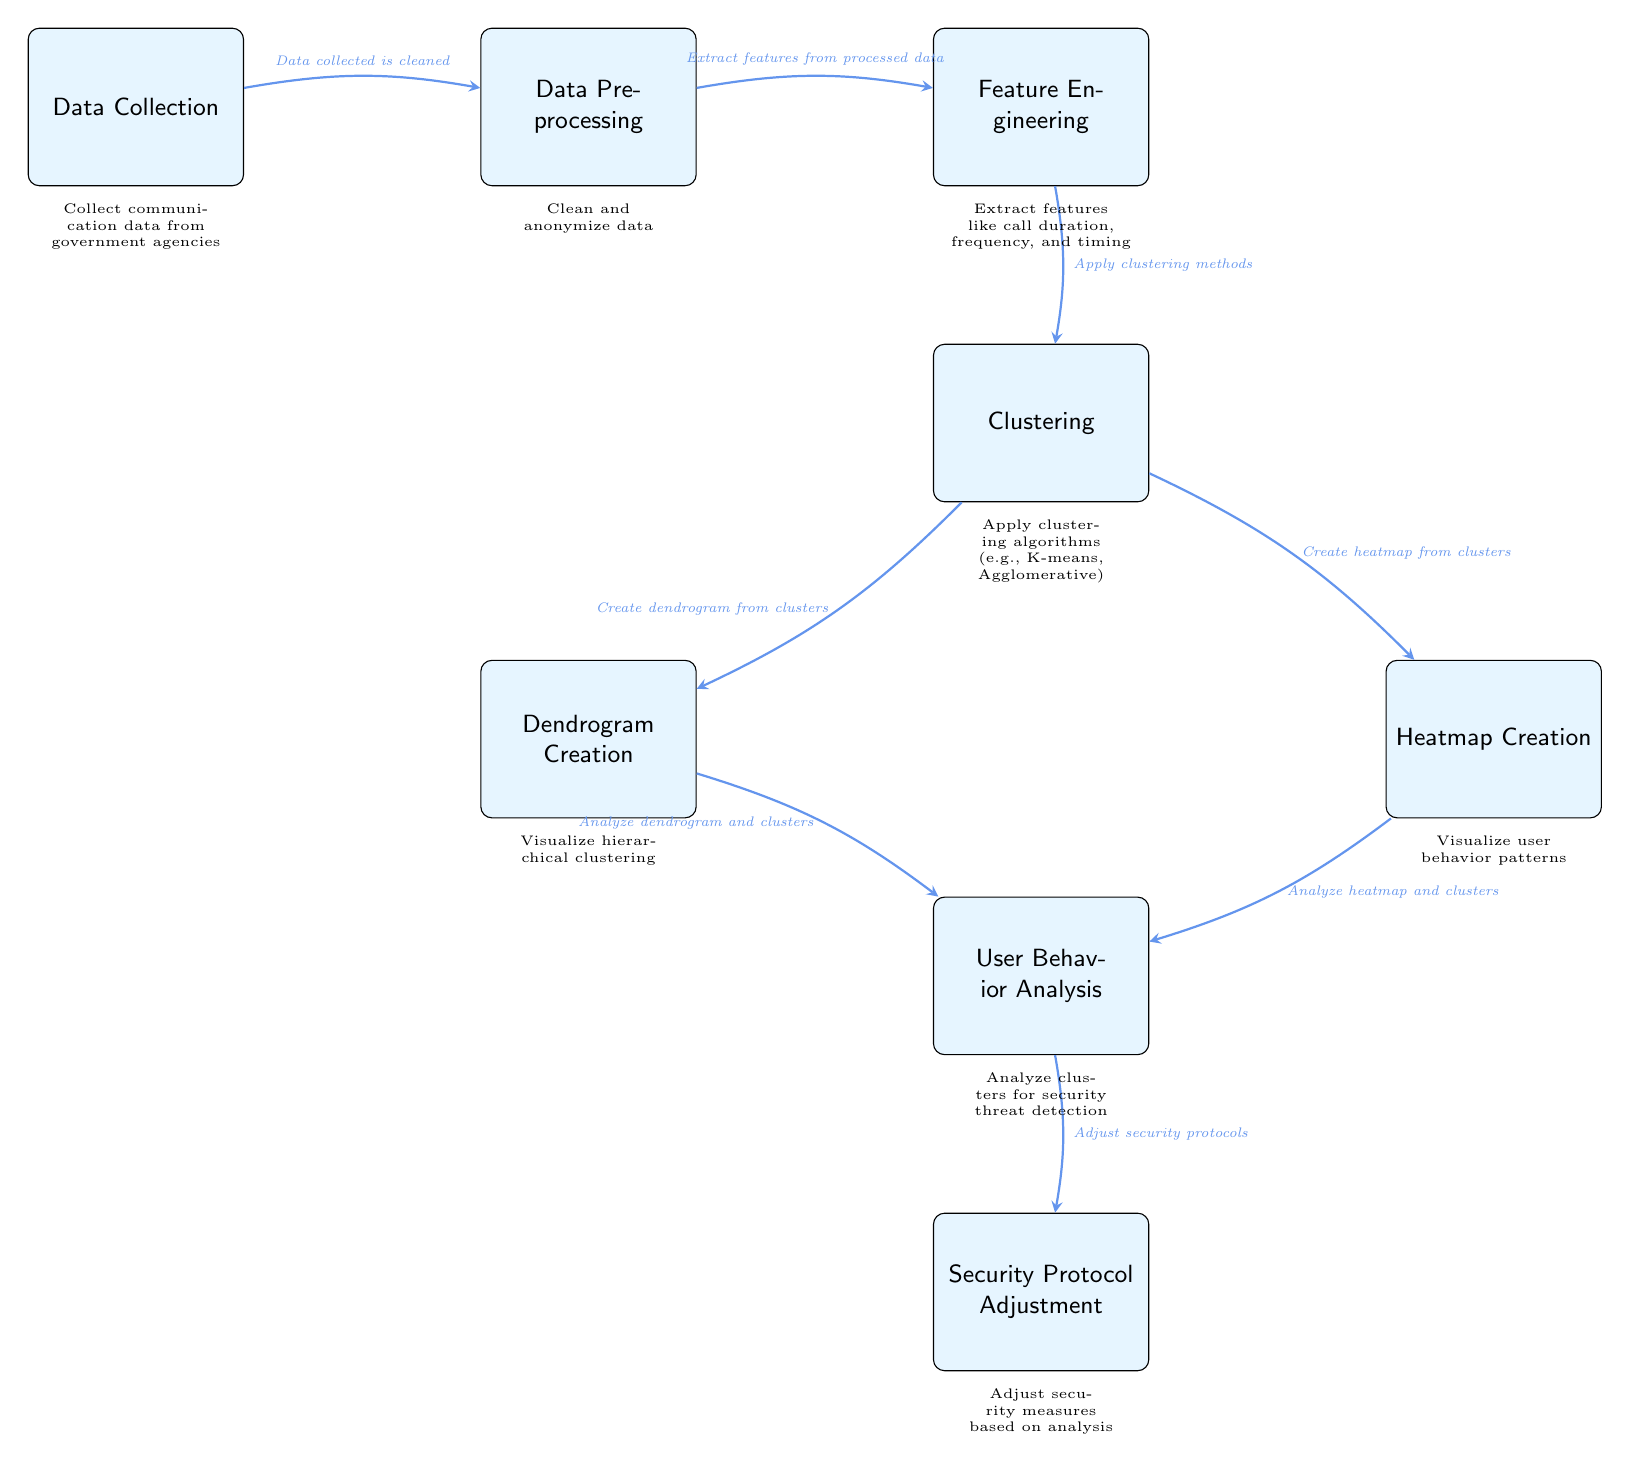What is the first step in the diagram? The first step in the diagram is represented by the node labeled "Data Collection," which indicates that data is collected from government agencies.
Answer: Data Collection How many main processes are shown in the diagram? By counting the nodes in the diagram, there are a total of eight main processes represented, from data collection to security protocol adjustment.
Answer: Eight What type of visualization is created from the clustering process? After the clustering process, two types of visualizations are created: a dendrogram and a heatmap, as indicated by the nodes directly connected to the Clustering node.
Answer: Dendrogram and Heatmap What task occurs after user behavior analysis? Once the User Behavior Analysis is complete, the next task indicated in the diagram is "Security Protocol Adjustment," which is how security measures are adapted based on the analysis findings.
Answer: Security Protocol Adjustment How does feature engineering relate to data preprocessing? Feature Engineering is directly connected to Data Preprocessing, as it follows this step in the process flow to extract relevant features from the processed data.
Answer: Extract features from processed data What clustering methods are specified in the diagram? The clustering methods referenced are K-means and Agglomerative, which are typical examples of clustering algorithms applied in this context.
Answer: K-means, Agglomerative What is created from the clusters according to the diagram? The diagram shows that both a dendrogram and a heatmap are created from the clusters, which serve to analyze user behavior patterns visually.
Answer: Dendrogram and Heatmap What does the arrow from Dendrogram Creation to User Behavior Analysis indicate? The arrow indicates that the analyzed dendrogram and its clusters contribute valuable insights that inform the User Behavior Analysis process that follows.
Answer: Analyze dendrogram and clusters Which step directly follows data collection? The step that directly follows Data Collection is Data Preprocessing, which involves cleaning and anonymizing the collected data for further processing.
Answer: Data Preprocessing 